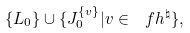<formula> <loc_0><loc_0><loc_500><loc_500>\{ L _ { 0 } \} \cup \{ J _ { 0 } ^ { \{ v \} } | v \in \ f h ^ { \natural } \} ,</formula> 